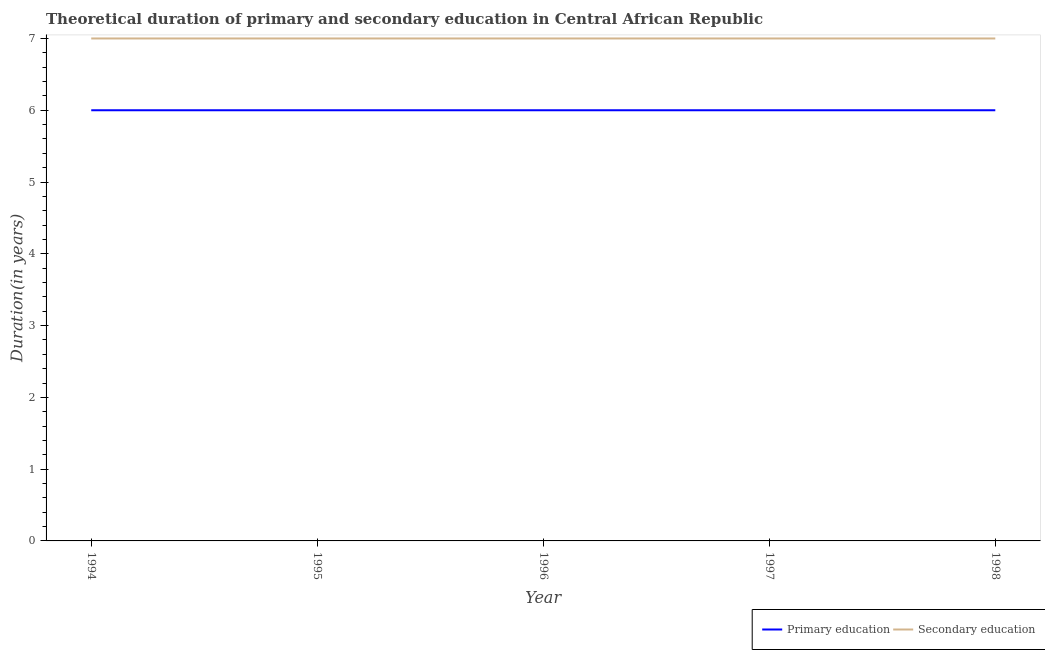How many different coloured lines are there?
Offer a terse response. 2. Does the line corresponding to duration of primary education intersect with the line corresponding to duration of secondary education?
Your answer should be compact. No. Is the number of lines equal to the number of legend labels?
Provide a short and direct response. Yes. Across all years, what is the maximum duration of primary education?
Keep it short and to the point. 6. Across all years, what is the minimum duration of secondary education?
Your response must be concise. 7. In which year was the duration of secondary education maximum?
Make the answer very short. 1994. What is the total duration of secondary education in the graph?
Your answer should be very brief. 35. What is the difference between the duration of primary education in 1994 and that in 1997?
Provide a short and direct response. 0. What is the difference between the duration of primary education in 1997 and the duration of secondary education in 1998?
Keep it short and to the point. -1. In the year 1998, what is the difference between the duration of secondary education and duration of primary education?
Give a very brief answer. 1. In how many years, is the duration of primary education greater than 4.6 years?
Your answer should be compact. 5. Is the difference between the duration of primary education in 1997 and 1998 greater than the difference between the duration of secondary education in 1997 and 1998?
Give a very brief answer. No. Is the duration of primary education strictly greater than the duration of secondary education over the years?
Offer a terse response. No. What is the difference between two consecutive major ticks on the Y-axis?
Offer a very short reply. 1. Does the graph contain any zero values?
Offer a very short reply. No. Does the graph contain grids?
Make the answer very short. No. Where does the legend appear in the graph?
Provide a short and direct response. Bottom right. What is the title of the graph?
Offer a terse response. Theoretical duration of primary and secondary education in Central African Republic. Does "Overweight" appear as one of the legend labels in the graph?
Give a very brief answer. No. What is the label or title of the Y-axis?
Provide a succinct answer. Duration(in years). What is the Duration(in years) of Primary education in 1994?
Provide a succinct answer. 6. What is the Duration(in years) of Secondary education in 1994?
Your response must be concise. 7. What is the Duration(in years) in Secondary education in 1995?
Give a very brief answer. 7. What is the Duration(in years) of Secondary education in 1997?
Offer a very short reply. 7. Across all years, what is the maximum Duration(in years) in Secondary education?
Ensure brevity in your answer.  7. Across all years, what is the minimum Duration(in years) in Primary education?
Offer a terse response. 6. Across all years, what is the minimum Duration(in years) in Secondary education?
Offer a very short reply. 7. What is the total Duration(in years) in Primary education in the graph?
Give a very brief answer. 30. What is the difference between the Duration(in years) of Secondary education in 1994 and that in 1995?
Provide a short and direct response. 0. What is the difference between the Duration(in years) in Primary education in 1994 and that in 1996?
Give a very brief answer. 0. What is the difference between the Duration(in years) of Secondary education in 1994 and that in 1996?
Your response must be concise. 0. What is the difference between the Duration(in years) in Secondary education in 1994 and that in 1997?
Your response must be concise. 0. What is the difference between the Duration(in years) of Secondary education in 1994 and that in 1998?
Keep it short and to the point. 0. What is the difference between the Duration(in years) of Primary education in 1995 and that in 1996?
Give a very brief answer. 0. What is the difference between the Duration(in years) of Secondary education in 1995 and that in 1996?
Give a very brief answer. 0. What is the difference between the Duration(in years) of Primary education in 1997 and that in 1998?
Ensure brevity in your answer.  0. What is the difference between the Duration(in years) of Primary education in 1994 and the Duration(in years) of Secondary education in 1995?
Make the answer very short. -1. What is the difference between the Duration(in years) in Primary education in 1994 and the Duration(in years) in Secondary education in 1997?
Offer a very short reply. -1. What is the difference between the Duration(in years) of Primary education in 1994 and the Duration(in years) of Secondary education in 1998?
Give a very brief answer. -1. What is the difference between the Duration(in years) of Primary education in 1995 and the Duration(in years) of Secondary education in 1997?
Give a very brief answer. -1. What is the difference between the Duration(in years) in Primary education in 1995 and the Duration(in years) in Secondary education in 1998?
Make the answer very short. -1. What is the difference between the Duration(in years) in Primary education in 1996 and the Duration(in years) in Secondary education in 1997?
Offer a very short reply. -1. In the year 1994, what is the difference between the Duration(in years) of Primary education and Duration(in years) of Secondary education?
Ensure brevity in your answer.  -1. In the year 1995, what is the difference between the Duration(in years) in Primary education and Duration(in years) in Secondary education?
Give a very brief answer. -1. In the year 1998, what is the difference between the Duration(in years) of Primary education and Duration(in years) of Secondary education?
Make the answer very short. -1. What is the ratio of the Duration(in years) in Primary education in 1994 to that in 1996?
Provide a short and direct response. 1. What is the ratio of the Duration(in years) of Secondary education in 1994 to that in 1996?
Provide a short and direct response. 1. What is the ratio of the Duration(in years) in Secondary education in 1994 to that in 1997?
Keep it short and to the point. 1. What is the ratio of the Duration(in years) of Primary education in 1994 to that in 1998?
Make the answer very short. 1. What is the ratio of the Duration(in years) in Secondary education in 1994 to that in 1998?
Offer a terse response. 1. What is the ratio of the Duration(in years) of Primary education in 1995 to that in 1996?
Give a very brief answer. 1. What is the ratio of the Duration(in years) in Primary education in 1995 to that in 1997?
Offer a terse response. 1. What is the ratio of the Duration(in years) in Primary education in 1995 to that in 1998?
Your response must be concise. 1. What is the ratio of the Duration(in years) of Secondary education in 1995 to that in 1998?
Give a very brief answer. 1. What is the ratio of the Duration(in years) in Primary education in 1996 to that in 1998?
Make the answer very short. 1. What is the ratio of the Duration(in years) of Secondary education in 1996 to that in 1998?
Your answer should be compact. 1. What is the difference between the highest and the lowest Duration(in years) in Secondary education?
Offer a terse response. 0. 